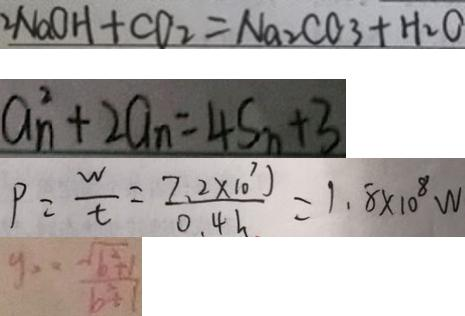Convert formula to latex. <formula><loc_0><loc_0><loc_500><loc_500>2 N a O H + C O _ { 2 } = N a _ { 2 } C O _ { 3 } + H _ { 2 } O 
 a _ { n } ^ { 2 } + 2 a _ { n } = 4 S _ { n } + 3 
 P = \frac { w } { t } = \frac { 7 . 2 \times 1 0 ^ { 7 } J } { 0 . 4 h } = 1 . 8 \times 1 0 ^ { 8 } W 
 y _ { 2 } = \frac { \sqrt { b ^ { 2 } + 1 } } { b ^ { 2 } + 1 }</formula> 